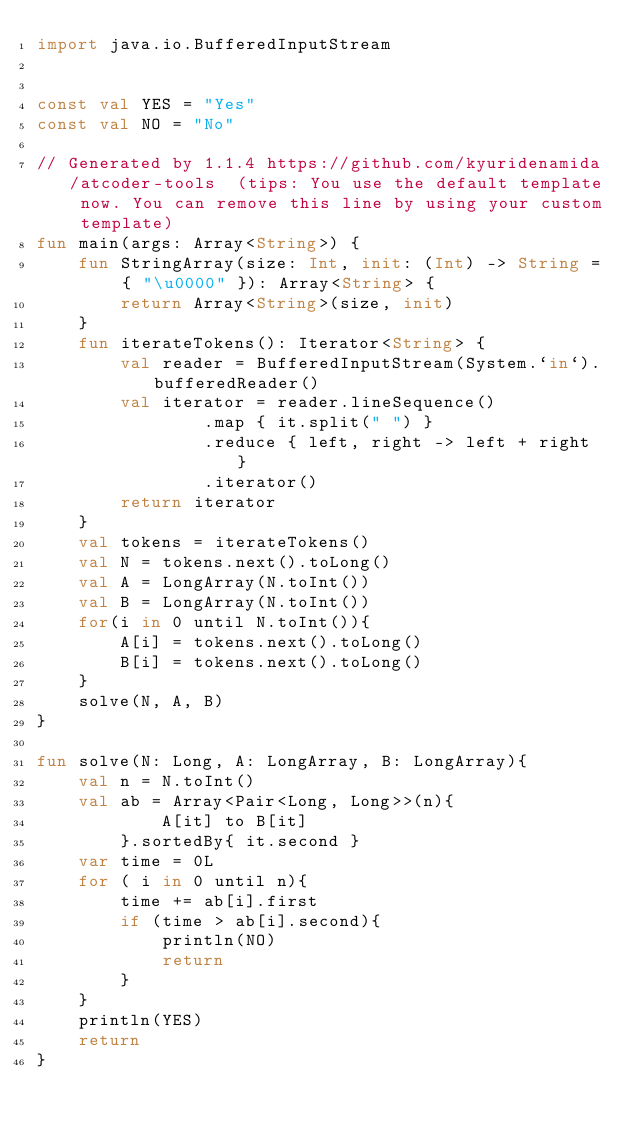<code> <loc_0><loc_0><loc_500><loc_500><_Kotlin_>import java.io.BufferedInputStream


const val YES = "Yes"
const val NO = "No"

// Generated by 1.1.4 https://github.com/kyuridenamida/atcoder-tools  (tips: You use the default template now. You can remove this line by using your custom template)
fun main(args: Array<String>) {
    fun StringArray(size: Int, init: (Int) -> String = { "\u0000" }): Array<String> {
        return Array<String>(size, init)
    }
    fun iterateTokens(): Iterator<String> {
        val reader = BufferedInputStream(System.`in`).bufferedReader()
        val iterator = reader.lineSequence()
                .map { it.split(" ") }
                .reduce { left, right -> left + right }
                .iterator()
        return iterator
    }
    val tokens = iterateTokens()
    val N = tokens.next().toLong()
    val A = LongArray(N.toInt())
    val B = LongArray(N.toInt())
    for(i in 0 until N.toInt()){
        A[i] = tokens.next().toLong()
        B[i] = tokens.next().toLong()
    }
    solve(N, A, B)
}

fun solve(N: Long, A: LongArray, B: LongArray){
    val n = N.toInt()
    val ab = Array<Pair<Long, Long>>(n){
            A[it] to B[it]
        }.sortedBy{ it.second }
    var time = 0L
    for ( i in 0 until n){
        time += ab[i].first
        if (time > ab[i].second){
            println(NO)
            return
        }
    }
    println(YES)
    return
}

</code> 